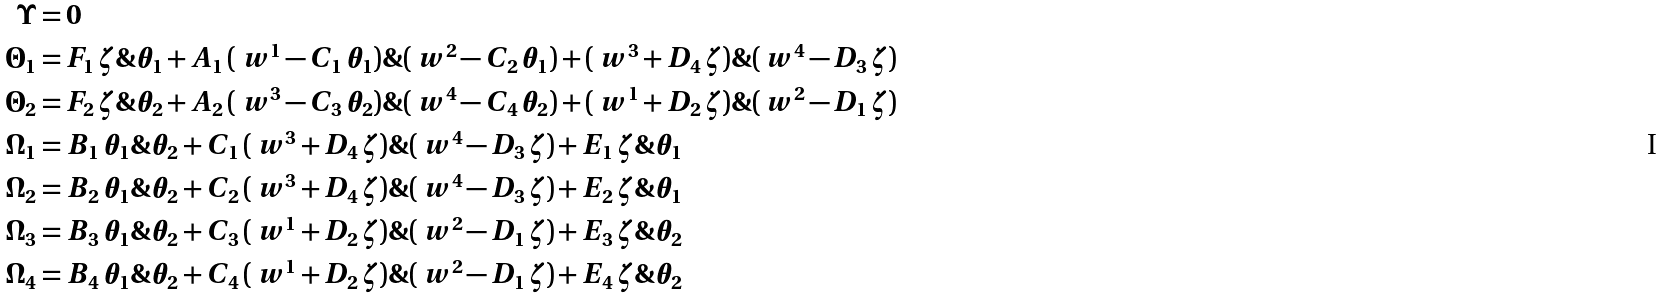Convert formula to latex. <formula><loc_0><loc_0><loc_500><loc_500>\Upsilon & = 0 \\ \Theta _ { 1 } & = F _ { 1 } \, \zeta \& \theta _ { 1 } + A _ { 1 } \, ( \ w ^ { 1 } - C _ { 1 } \, \theta _ { 1 } ) \& ( \ w ^ { 2 } - C _ { 2 } \, \theta _ { 1 } ) + ( \ w ^ { 3 } + D _ { 4 } \, \zeta ) \& ( \ w ^ { 4 } - D _ { 3 } \, \zeta ) \\ \Theta _ { 2 } & = F _ { 2 } \, \zeta \& \theta _ { 2 } + A _ { 2 } \, ( \ w ^ { 3 } - C _ { 3 } \, \theta _ { 2 } ) \& ( \ w ^ { 4 } - C _ { 4 } \, \theta _ { 2 } ) + ( \ w ^ { 1 } + D _ { 2 } \, \zeta ) \& ( \ w ^ { 2 } - D _ { 1 } \, \zeta ) \\ \Omega _ { 1 } & = B _ { 1 } \, \theta _ { 1 } \& \theta _ { 2 } + C _ { 1 } \, ( \ w ^ { 3 } + D _ { 4 } \, \zeta ) \& ( \ w ^ { 4 } - D _ { 3 } \, \zeta ) + E _ { 1 } \, \zeta \& \theta _ { 1 } \\ \Omega _ { 2 } & = B _ { 2 } \, \theta _ { 1 } \& \theta _ { 2 } + C _ { 2 } \, ( \ w ^ { 3 } + D _ { 4 } \, \zeta ) \& ( \ w ^ { 4 } - D _ { 3 } \, \zeta ) + E _ { 2 } \, \zeta \& \theta _ { 1 } \\ \Omega _ { 3 } & = B _ { 3 } \, \theta _ { 1 } \& \theta _ { 2 } + C _ { 3 } \, ( \ w ^ { 1 } + D _ { 2 } \, \zeta ) \& ( \ w ^ { 2 } - D _ { 1 } \, \zeta ) + E _ { 3 } \, \zeta \& \theta _ { 2 } \\ \Omega _ { 4 } & = B _ { 4 } \, \theta _ { 1 } \& \theta _ { 2 } + C _ { 4 } \, ( \ w ^ { 1 } + D _ { 2 } \, \zeta ) \& ( \ w ^ { 2 } - D _ { 1 } \, \zeta ) + E _ { 4 } \, \zeta \& \theta _ { 2 }</formula> 